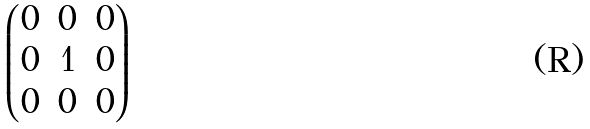Convert formula to latex. <formula><loc_0><loc_0><loc_500><loc_500>\begin{pmatrix} 0 & 0 & 0 \\ 0 & 1 & 0 \\ 0 & 0 & 0 \end{pmatrix}</formula> 